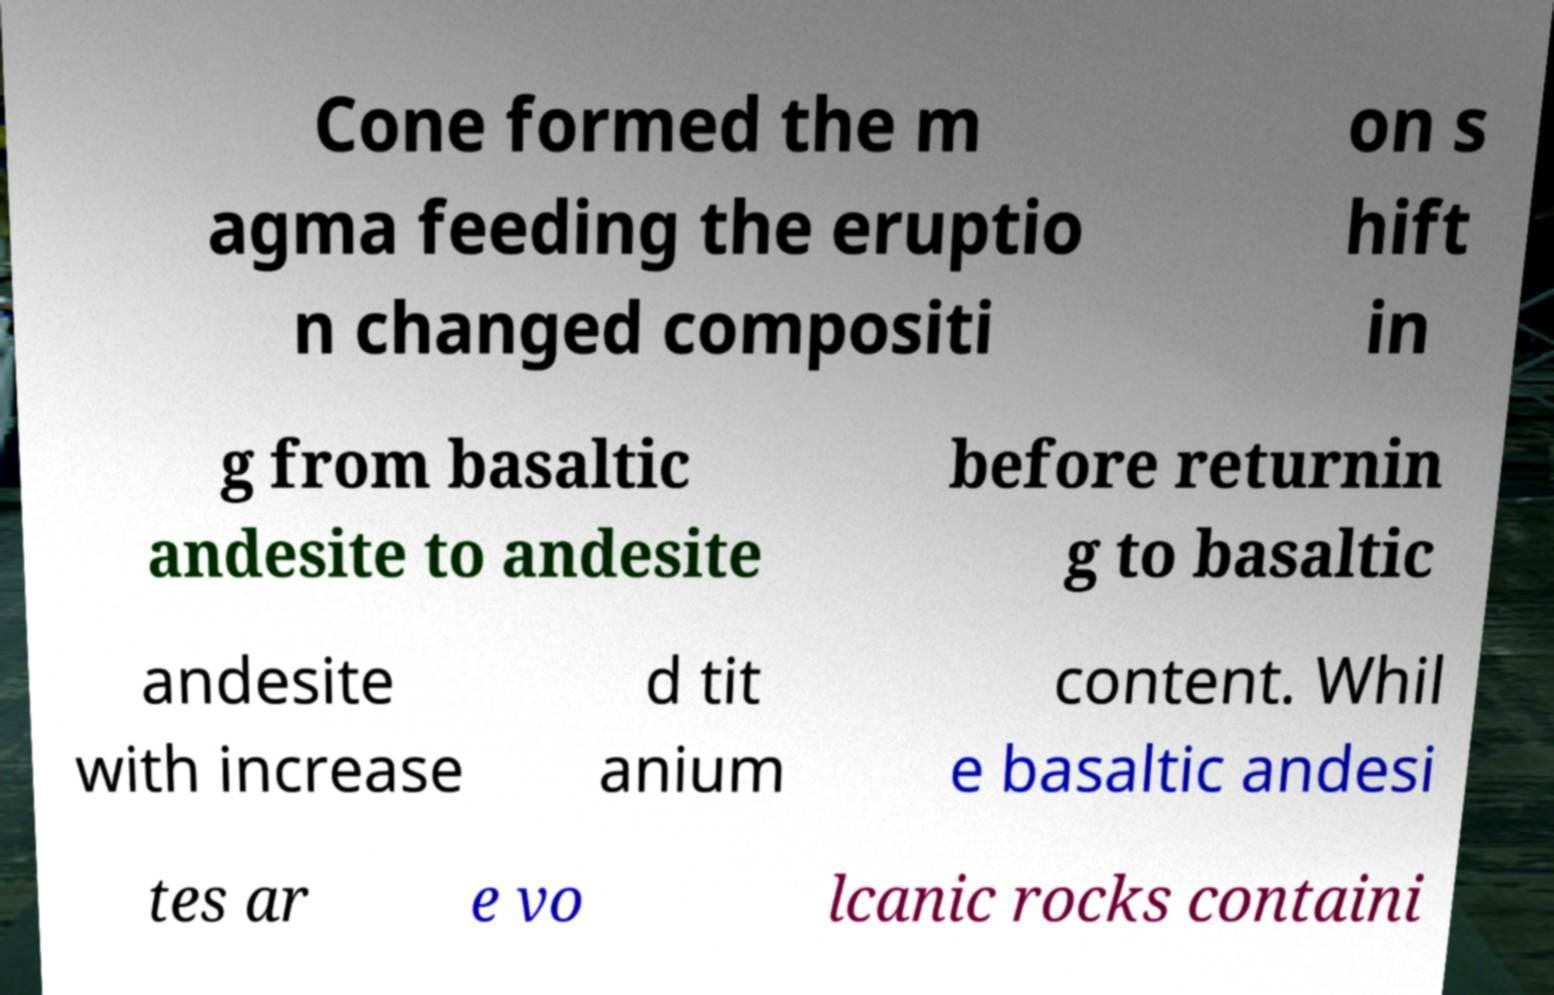Can you read and provide the text displayed in the image?This photo seems to have some interesting text. Can you extract and type it out for me? Cone formed the m agma feeding the eruptio n changed compositi on s hift in g from basaltic andesite to andesite before returnin g to basaltic andesite with increase d tit anium content. Whil e basaltic andesi tes ar e vo lcanic rocks containi 